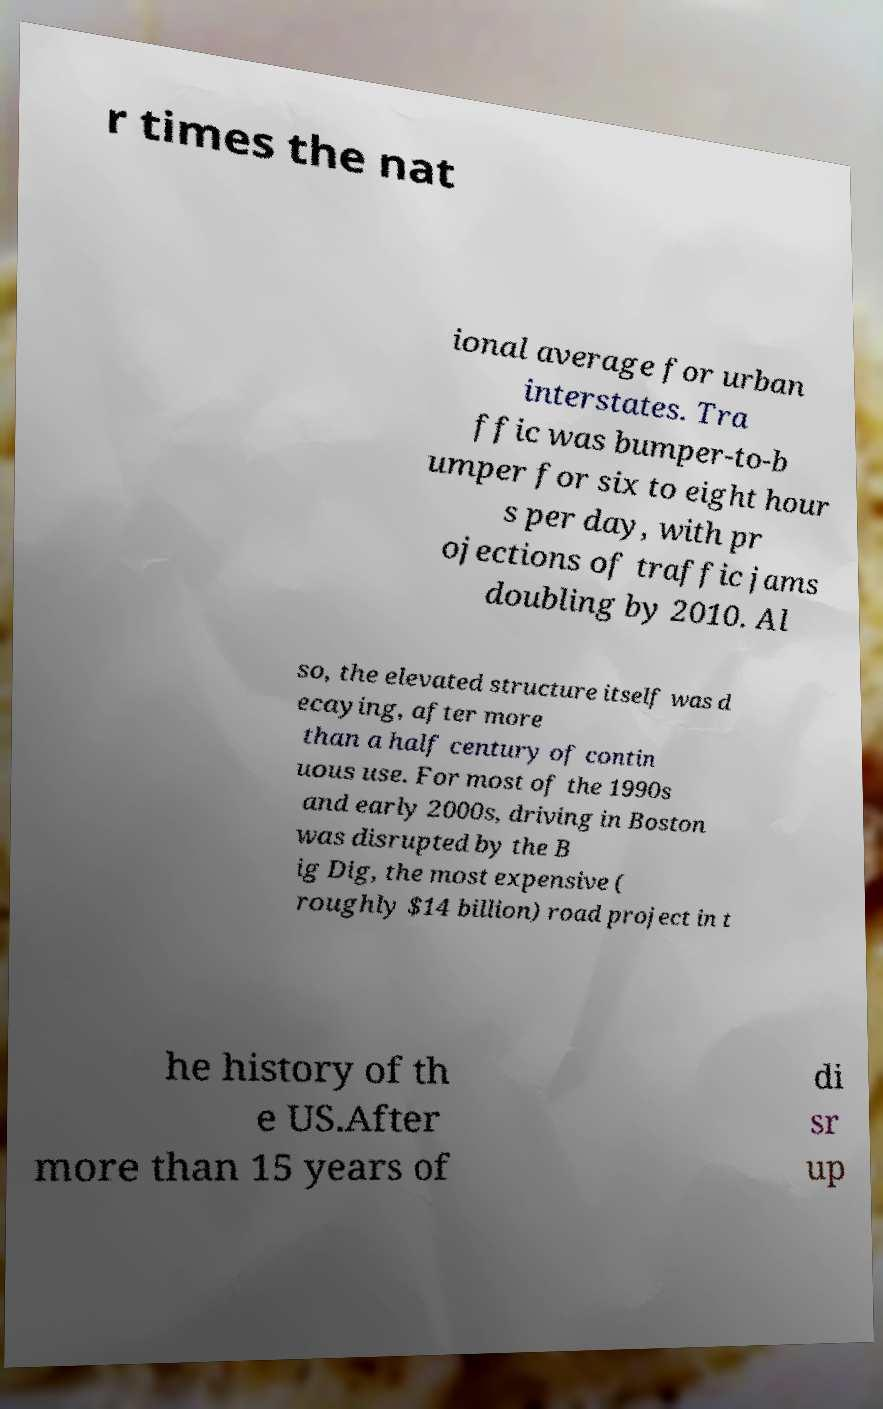Please identify and transcribe the text found in this image. r times the nat ional average for urban interstates. Tra ffic was bumper-to-b umper for six to eight hour s per day, with pr ojections of traffic jams doubling by 2010. Al so, the elevated structure itself was d ecaying, after more than a half century of contin uous use. For most of the 1990s and early 2000s, driving in Boston was disrupted by the B ig Dig, the most expensive ( roughly $14 billion) road project in t he history of th e US.After more than 15 years of di sr up 